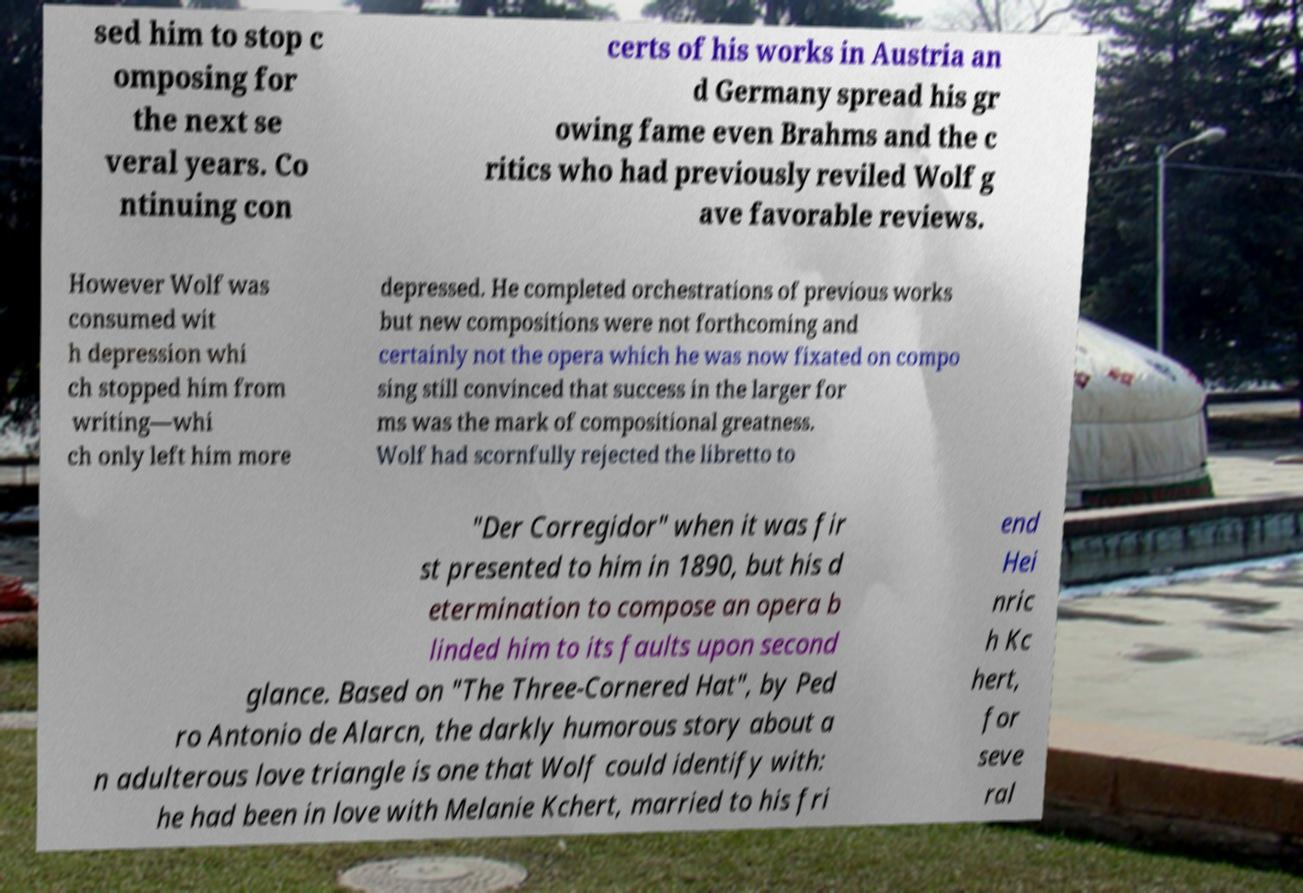Could you assist in decoding the text presented in this image and type it out clearly? sed him to stop c omposing for the next se veral years. Co ntinuing con certs of his works in Austria an d Germany spread his gr owing fame even Brahms and the c ritics who had previously reviled Wolf g ave favorable reviews. However Wolf was consumed wit h depression whi ch stopped him from writing—whi ch only left him more depressed. He completed orchestrations of previous works but new compositions were not forthcoming and certainly not the opera which he was now fixated on compo sing still convinced that success in the larger for ms was the mark of compositional greatness. Wolf had scornfully rejected the libretto to "Der Corregidor" when it was fir st presented to him in 1890, but his d etermination to compose an opera b linded him to its faults upon second glance. Based on "The Three-Cornered Hat", by Ped ro Antonio de Alarcn, the darkly humorous story about a n adulterous love triangle is one that Wolf could identify with: he had been in love with Melanie Kchert, married to his fri end Hei nric h Kc hert, for seve ral 